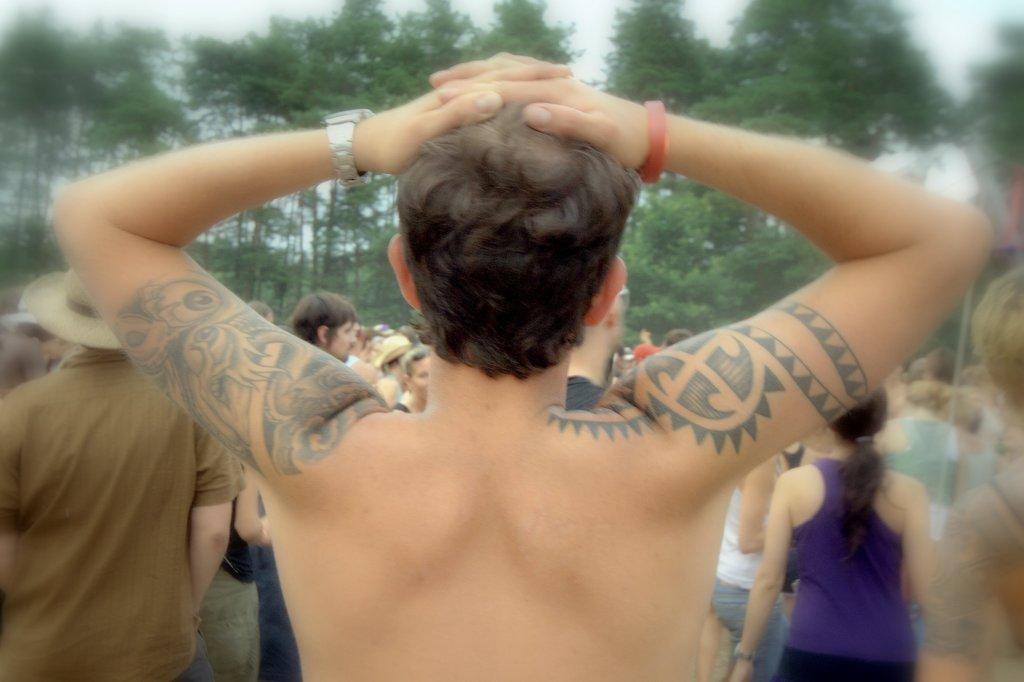What is the man in the image doing? The man is standing on a path in the image. What is happening in front of the man? There are groups of people in front of the man. What type of natural environment can be seen in the image? There are trees visible in the image. What is visible above the people and trees in the image? The sky is visible in the image. What type of water is being used for digestion in the image? There is no reference to water or digestion in the image; it features a man standing on a path with groups of people in front of him, surrounded by trees and sky. 